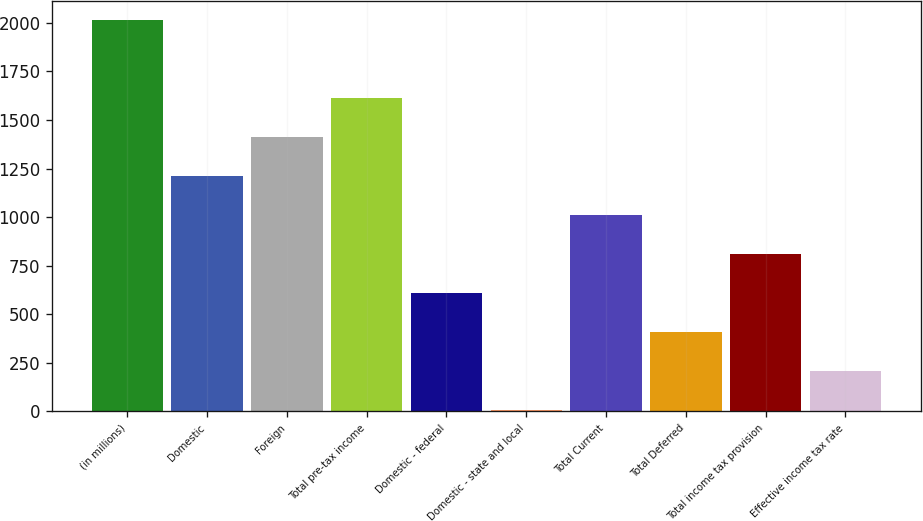<chart> <loc_0><loc_0><loc_500><loc_500><bar_chart><fcel>(in millions)<fcel>Domestic<fcel>Foreign<fcel>Total pre-tax income<fcel>Domestic - federal<fcel>Domestic - state and local<fcel>Total Current<fcel>Total Deferred<fcel>Total income tax provision<fcel>Effective income tax rate<nl><fcel>2014<fcel>1211.2<fcel>1411.9<fcel>1612.6<fcel>609.1<fcel>7<fcel>1010.5<fcel>408.4<fcel>809.8<fcel>207.7<nl></chart> 